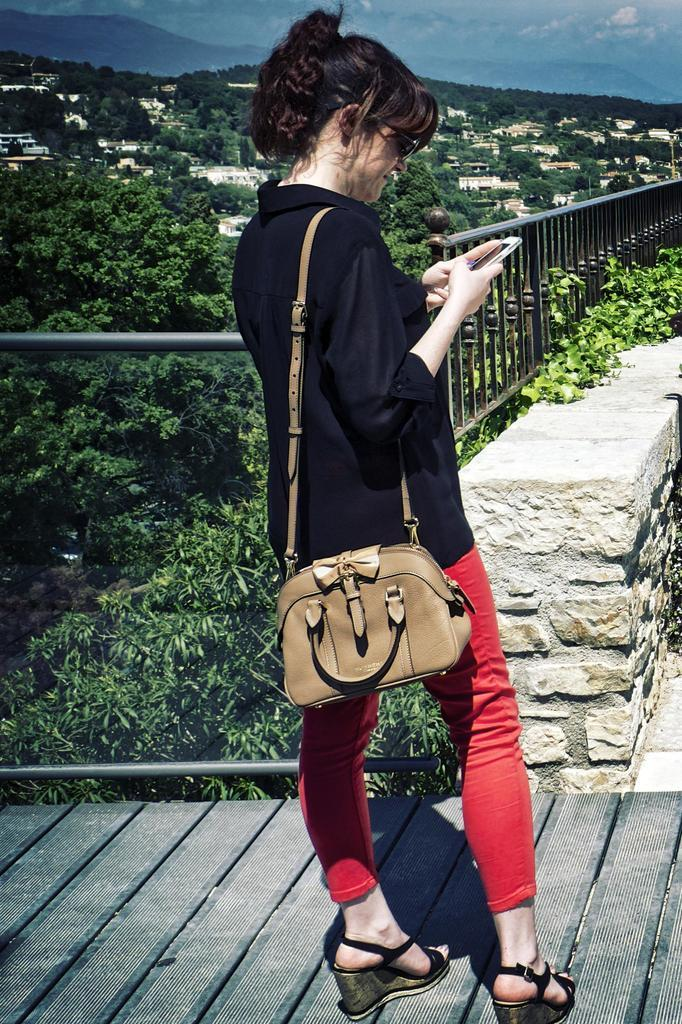What is the person in the image doing? The person is standing. What object is the person holding in the image? The person is holding a mobile. What accessory is the person wearing in the image? The person is wearing a bag. What can be seen in the background of the image? There are trees, houses, the sky, and a fence in the background. What type of ink is being used to write on the building in the image? There is no building present in the image, and therefore no ink or writing can be observed. 